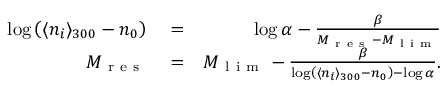Convert formula to latex. <formula><loc_0><loc_0><loc_500><loc_500>\begin{array} { r l r } { \log \left ( \langle n _ { i } \rangle _ { 3 0 0 } - n _ { 0 } \right ) } & = } & { \log \alpha - \frac { \beta } { M _ { r e s } - M _ { l i m } } } \\ { M _ { r e s } } & = } & { M _ { l i m } - \frac { \beta } { \log \left ( \langle n _ { i } \rangle _ { 3 0 0 } - n _ { 0 } \right ) - \log \alpha } . } \end{array}</formula> 